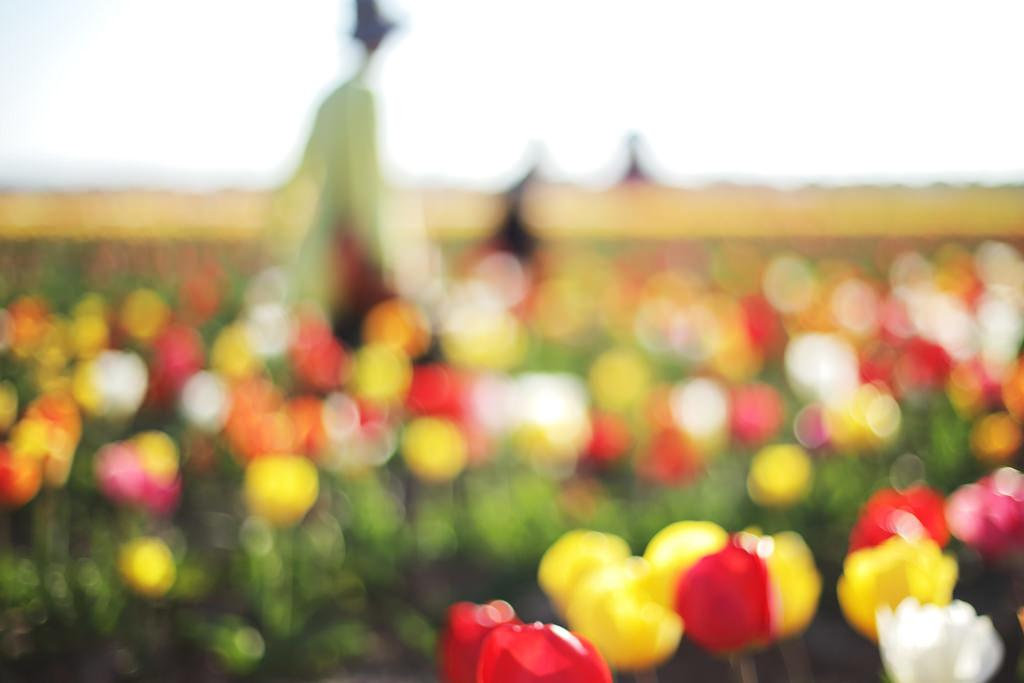What type of plants can be seen in the image? There are flowers in the image. Can you describe the background of the image? The background is blurry. What type of wheel is visible in the image? There is no wheel present in the image; it features flowers and a blurry background. What event is taking place in the image? There is no event depicted in the image; it simply shows flowers and a blurry background. 